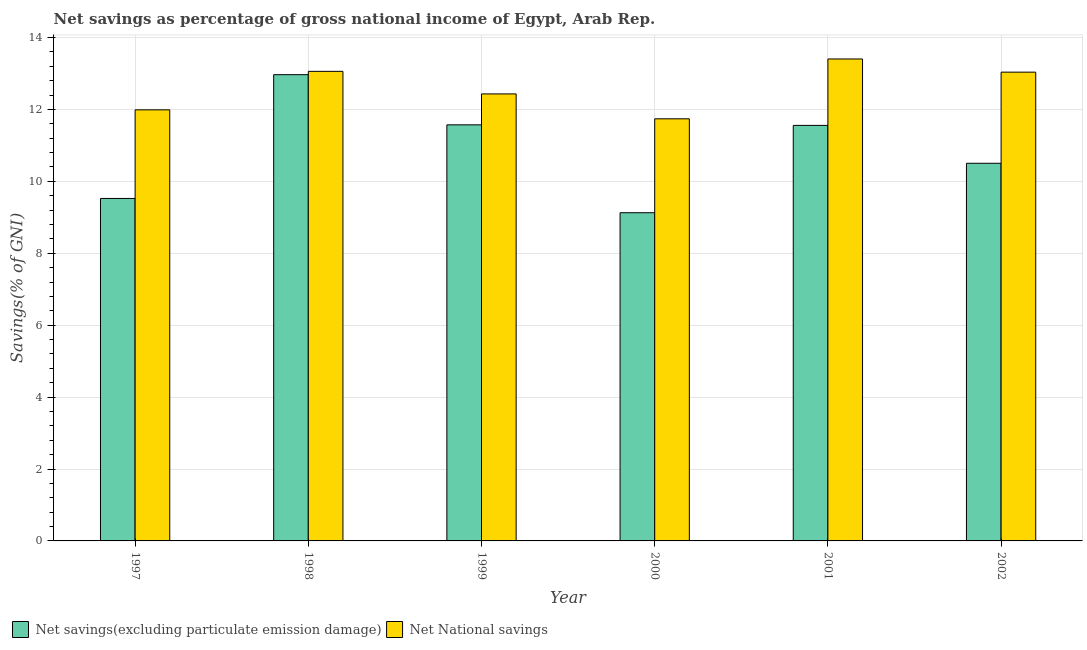Are the number of bars per tick equal to the number of legend labels?
Offer a very short reply. Yes. How many bars are there on the 2nd tick from the right?
Make the answer very short. 2. In how many cases, is the number of bars for a given year not equal to the number of legend labels?
Keep it short and to the point. 0. What is the net national savings in 1998?
Your response must be concise. 13.06. Across all years, what is the maximum net national savings?
Keep it short and to the point. 13.4. Across all years, what is the minimum net national savings?
Your answer should be very brief. 11.74. In which year was the net national savings maximum?
Your response must be concise. 2001. In which year was the net national savings minimum?
Your answer should be compact. 2000. What is the total net savings(excluding particulate emission damage) in the graph?
Ensure brevity in your answer.  65.25. What is the difference between the net savings(excluding particulate emission damage) in 1999 and that in 2000?
Offer a terse response. 2.44. What is the difference between the net national savings in 2001 and the net savings(excluding particulate emission damage) in 2002?
Give a very brief answer. 0.37. What is the average net savings(excluding particulate emission damage) per year?
Your answer should be compact. 10.87. In the year 2000, what is the difference between the net savings(excluding particulate emission damage) and net national savings?
Ensure brevity in your answer.  0. What is the ratio of the net national savings in 1998 to that in 1999?
Ensure brevity in your answer.  1.05. Is the net savings(excluding particulate emission damage) in 1999 less than that in 2002?
Your answer should be compact. No. What is the difference between the highest and the second highest net national savings?
Offer a terse response. 0.34. What is the difference between the highest and the lowest net national savings?
Offer a terse response. 1.66. What does the 1st bar from the left in 1997 represents?
Offer a terse response. Net savings(excluding particulate emission damage). What does the 2nd bar from the right in 1998 represents?
Offer a terse response. Net savings(excluding particulate emission damage). Does the graph contain grids?
Provide a succinct answer. Yes. Where does the legend appear in the graph?
Keep it short and to the point. Bottom left. How many legend labels are there?
Your answer should be very brief. 2. How are the legend labels stacked?
Keep it short and to the point. Horizontal. What is the title of the graph?
Your answer should be very brief. Net savings as percentage of gross national income of Egypt, Arab Rep. What is the label or title of the Y-axis?
Your response must be concise. Savings(% of GNI). What is the Savings(% of GNI) in Net savings(excluding particulate emission damage) in 1997?
Make the answer very short. 9.52. What is the Savings(% of GNI) of Net National savings in 1997?
Keep it short and to the point. 11.99. What is the Savings(% of GNI) in Net savings(excluding particulate emission damage) in 1998?
Keep it short and to the point. 12.97. What is the Savings(% of GNI) of Net National savings in 1998?
Provide a succinct answer. 13.06. What is the Savings(% of GNI) in Net savings(excluding particulate emission damage) in 1999?
Ensure brevity in your answer.  11.57. What is the Savings(% of GNI) of Net National savings in 1999?
Provide a succinct answer. 12.43. What is the Savings(% of GNI) in Net savings(excluding particulate emission damage) in 2000?
Offer a terse response. 9.13. What is the Savings(% of GNI) in Net National savings in 2000?
Your answer should be compact. 11.74. What is the Savings(% of GNI) of Net savings(excluding particulate emission damage) in 2001?
Keep it short and to the point. 11.56. What is the Savings(% of GNI) in Net National savings in 2001?
Make the answer very short. 13.4. What is the Savings(% of GNI) in Net savings(excluding particulate emission damage) in 2002?
Offer a terse response. 10.5. What is the Savings(% of GNI) of Net National savings in 2002?
Offer a very short reply. 13.04. Across all years, what is the maximum Savings(% of GNI) of Net savings(excluding particulate emission damage)?
Ensure brevity in your answer.  12.97. Across all years, what is the maximum Savings(% of GNI) in Net National savings?
Provide a succinct answer. 13.4. Across all years, what is the minimum Savings(% of GNI) in Net savings(excluding particulate emission damage)?
Ensure brevity in your answer.  9.13. Across all years, what is the minimum Savings(% of GNI) in Net National savings?
Make the answer very short. 11.74. What is the total Savings(% of GNI) in Net savings(excluding particulate emission damage) in the graph?
Provide a short and direct response. 65.25. What is the total Savings(% of GNI) of Net National savings in the graph?
Make the answer very short. 75.65. What is the difference between the Savings(% of GNI) of Net savings(excluding particulate emission damage) in 1997 and that in 1998?
Provide a succinct answer. -3.44. What is the difference between the Savings(% of GNI) of Net National savings in 1997 and that in 1998?
Your answer should be compact. -1.07. What is the difference between the Savings(% of GNI) in Net savings(excluding particulate emission damage) in 1997 and that in 1999?
Give a very brief answer. -2.05. What is the difference between the Savings(% of GNI) of Net National savings in 1997 and that in 1999?
Offer a very short reply. -0.44. What is the difference between the Savings(% of GNI) in Net savings(excluding particulate emission damage) in 1997 and that in 2000?
Offer a terse response. 0.4. What is the difference between the Savings(% of GNI) of Net National savings in 1997 and that in 2000?
Offer a terse response. 0.25. What is the difference between the Savings(% of GNI) of Net savings(excluding particulate emission damage) in 1997 and that in 2001?
Offer a very short reply. -2.03. What is the difference between the Savings(% of GNI) of Net National savings in 1997 and that in 2001?
Offer a terse response. -1.41. What is the difference between the Savings(% of GNI) in Net savings(excluding particulate emission damage) in 1997 and that in 2002?
Make the answer very short. -0.98. What is the difference between the Savings(% of GNI) in Net National savings in 1997 and that in 2002?
Offer a terse response. -1.05. What is the difference between the Savings(% of GNI) in Net savings(excluding particulate emission damage) in 1998 and that in 1999?
Provide a succinct answer. 1.39. What is the difference between the Savings(% of GNI) in Net National savings in 1998 and that in 1999?
Make the answer very short. 0.63. What is the difference between the Savings(% of GNI) of Net savings(excluding particulate emission damage) in 1998 and that in 2000?
Your response must be concise. 3.84. What is the difference between the Savings(% of GNI) in Net National savings in 1998 and that in 2000?
Offer a terse response. 1.32. What is the difference between the Savings(% of GNI) in Net savings(excluding particulate emission damage) in 1998 and that in 2001?
Your answer should be very brief. 1.41. What is the difference between the Savings(% of GNI) of Net National savings in 1998 and that in 2001?
Give a very brief answer. -0.34. What is the difference between the Savings(% of GNI) in Net savings(excluding particulate emission damage) in 1998 and that in 2002?
Your response must be concise. 2.46. What is the difference between the Savings(% of GNI) in Net National savings in 1998 and that in 2002?
Ensure brevity in your answer.  0.02. What is the difference between the Savings(% of GNI) in Net savings(excluding particulate emission damage) in 1999 and that in 2000?
Provide a succinct answer. 2.44. What is the difference between the Savings(% of GNI) in Net National savings in 1999 and that in 2000?
Make the answer very short. 0.69. What is the difference between the Savings(% of GNI) of Net savings(excluding particulate emission damage) in 1999 and that in 2001?
Provide a short and direct response. 0.02. What is the difference between the Savings(% of GNI) in Net National savings in 1999 and that in 2001?
Offer a terse response. -0.97. What is the difference between the Savings(% of GNI) of Net savings(excluding particulate emission damage) in 1999 and that in 2002?
Keep it short and to the point. 1.07. What is the difference between the Savings(% of GNI) in Net National savings in 1999 and that in 2002?
Your answer should be compact. -0.61. What is the difference between the Savings(% of GNI) of Net savings(excluding particulate emission damage) in 2000 and that in 2001?
Ensure brevity in your answer.  -2.43. What is the difference between the Savings(% of GNI) in Net National savings in 2000 and that in 2001?
Provide a succinct answer. -1.66. What is the difference between the Savings(% of GNI) in Net savings(excluding particulate emission damage) in 2000 and that in 2002?
Give a very brief answer. -1.38. What is the difference between the Savings(% of GNI) in Net National savings in 2000 and that in 2002?
Ensure brevity in your answer.  -1.3. What is the difference between the Savings(% of GNI) in Net savings(excluding particulate emission damage) in 2001 and that in 2002?
Provide a succinct answer. 1.05. What is the difference between the Savings(% of GNI) in Net National savings in 2001 and that in 2002?
Keep it short and to the point. 0.37. What is the difference between the Savings(% of GNI) in Net savings(excluding particulate emission damage) in 1997 and the Savings(% of GNI) in Net National savings in 1998?
Make the answer very short. -3.53. What is the difference between the Savings(% of GNI) of Net savings(excluding particulate emission damage) in 1997 and the Savings(% of GNI) of Net National savings in 1999?
Ensure brevity in your answer.  -2.91. What is the difference between the Savings(% of GNI) of Net savings(excluding particulate emission damage) in 1997 and the Savings(% of GNI) of Net National savings in 2000?
Your response must be concise. -2.21. What is the difference between the Savings(% of GNI) in Net savings(excluding particulate emission damage) in 1997 and the Savings(% of GNI) in Net National savings in 2001?
Give a very brief answer. -3.88. What is the difference between the Savings(% of GNI) in Net savings(excluding particulate emission damage) in 1997 and the Savings(% of GNI) in Net National savings in 2002?
Your response must be concise. -3.51. What is the difference between the Savings(% of GNI) of Net savings(excluding particulate emission damage) in 1998 and the Savings(% of GNI) of Net National savings in 1999?
Make the answer very short. 0.53. What is the difference between the Savings(% of GNI) in Net savings(excluding particulate emission damage) in 1998 and the Savings(% of GNI) in Net National savings in 2000?
Your answer should be compact. 1.23. What is the difference between the Savings(% of GNI) in Net savings(excluding particulate emission damage) in 1998 and the Savings(% of GNI) in Net National savings in 2001?
Offer a terse response. -0.44. What is the difference between the Savings(% of GNI) of Net savings(excluding particulate emission damage) in 1998 and the Savings(% of GNI) of Net National savings in 2002?
Your response must be concise. -0.07. What is the difference between the Savings(% of GNI) of Net savings(excluding particulate emission damage) in 1999 and the Savings(% of GNI) of Net National savings in 2000?
Make the answer very short. -0.17. What is the difference between the Savings(% of GNI) of Net savings(excluding particulate emission damage) in 1999 and the Savings(% of GNI) of Net National savings in 2001?
Provide a succinct answer. -1.83. What is the difference between the Savings(% of GNI) of Net savings(excluding particulate emission damage) in 1999 and the Savings(% of GNI) of Net National savings in 2002?
Offer a very short reply. -1.47. What is the difference between the Savings(% of GNI) in Net savings(excluding particulate emission damage) in 2000 and the Savings(% of GNI) in Net National savings in 2001?
Offer a very short reply. -4.28. What is the difference between the Savings(% of GNI) of Net savings(excluding particulate emission damage) in 2000 and the Savings(% of GNI) of Net National savings in 2002?
Give a very brief answer. -3.91. What is the difference between the Savings(% of GNI) of Net savings(excluding particulate emission damage) in 2001 and the Savings(% of GNI) of Net National savings in 2002?
Make the answer very short. -1.48. What is the average Savings(% of GNI) in Net savings(excluding particulate emission damage) per year?
Give a very brief answer. 10.87. What is the average Savings(% of GNI) in Net National savings per year?
Provide a succinct answer. 12.61. In the year 1997, what is the difference between the Savings(% of GNI) in Net savings(excluding particulate emission damage) and Savings(% of GNI) in Net National savings?
Your answer should be very brief. -2.46. In the year 1998, what is the difference between the Savings(% of GNI) in Net savings(excluding particulate emission damage) and Savings(% of GNI) in Net National savings?
Provide a succinct answer. -0.09. In the year 1999, what is the difference between the Savings(% of GNI) in Net savings(excluding particulate emission damage) and Savings(% of GNI) in Net National savings?
Your response must be concise. -0.86. In the year 2000, what is the difference between the Savings(% of GNI) in Net savings(excluding particulate emission damage) and Savings(% of GNI) in Net National savings?
Ensure brevity in your answer.  -2.61. In the year 2001, what is the difference between the Savings(% of GNI) in Net savings(excluding particulate emission damage) and Savings(% of GNI) in Net National savings?
Provide a succinct answer. -1.85. In the year 2002, what is the difference between the Savings(% of GNI) of Net savings(excluding particulate emission damage) and Savings(% of GNI) of Net National savings?
Your response must be concise. -2.53. What is the ratio of the Savings(% of GNI) of Net savings(excluding particulate emission damage) in 1997 to that in 1998?
Provide a succinct answer. 0.73. What is the ratio of the Savings(% of GNI) of Net National savings in 1997 to that in 1998?
Provide a short and direct response. 0.92. What is the ratio of the Savings(% of GNI) of Net savings(excluding particulate emission damage) in 1997 to that in 1999?
Your answer should be compact. 0.82. What is the ratio of the Savings(% of GNI) of Net National savings in 1997 to that in 1999?
Make the answer very short. 0.96. What is the ratio of the Savings(% of GNI) of Net savings(excluding particulate emission damage) in 1997 to that in 2000?
Provide a succinct answer. 1.04. What is the ratio of the Savings(% of GNI) of Net National savings in 1997 to that in 2000?
Provide a succinct answer. 1.02. What is the ratio of the Savings(% of GNI) in Net savings(excluding particulate emission damage) in 1997 to that in 2001?
Your answer should be compact. 0.82. What is the ratio of the Savings(% of GNI) in Net National savings in 1997 to that in 2001?
Your answer should be very brief. 0.89. What is the ratio of the Savings(% of GNI) in Net savings(excluding particulate emission damage) in 1997 to that in 2002?
Offer a terse response. 0.91. What is the ratio of the Savings(% of GNI) of Net National savings in 1997 to that in 2002?
Make the answer very short. 0.92. What is the ratio of the Savings(% of GNI) in Net savings(excluding particulate emission damage) in 1998 to that in 1999?
Offer a very short reply. 1.12. What is the ratio of the Savings(% of GNI) in Net National savings in 1998 to that in 1999?
Offer a terse response. 1.05. What is the ratio of the Savings(% of GNI) of Net savings(excluding particulate emission damage) in 1998 to that in 2000?
Offer a very short reply. 1.42. What is the ratio of the Savings(% of GNI) in Net National savings in 1998 to that in 2000?
Provide a short and direct response. 1.11. What is the ratio of the Savings(% of GNI) in Net savings(excluding particulate emission damage) in 1998 to that in 2001?
Your answer should be very brief. 1.12. What is the ratio of the Savings(% of GNI) of Net National savings in 1998 to that in 2001?
Your answer should be very brief. 0.97. What is the ratio of the Savings(% of GNI) of Net savings(excluding particulate emission damage) in 1998 to that in 2002?
Offer a terse response. 1.23. What is the ratio of the Savings(% of GNI) in Net savings(excluding particulate emission damage) in 1999 to that in 2000?
Offer a terse response. 1.27. What is the ratio of the Savings(% of GNI) in Net National savings in 1999 to that in 2000?
Keep it short and to the point. 1.06. What is the ratio of the Savings(% of GNI) in Net savings(excluding particulate emission damage) in 1999 to that in 2001?
Your answer should be very brief. 1. What is the ratio of the Savings(% of GNI) in Net National savings in 1999 to that in 2001?
Offer a terse response. 0.93. What is the ratio of the Savings(% of GNI) in Net savings(excluding particulate emission damage) in 1999 to that in 2002?
Your response must be concise. 1.1. What is the ratio of the Savings(% of GNI) of Net National savings in 1999 to that in 2002?
Keep it short and to the point. 0.95. What is the ratio of the Savings(% of GNI) of Net savings(excluding particulate emission damage) in 2000 to that in 2001?
Offer a terse response. 0.79. What is the ratio of the Savings(% of GNI) of Net National savings in 2000 to that in 2001?
Make the answer very short. 0.88. What is the ratio of the Savings(% of GNI) of Net savings(excluding particulate emission damage) in 2000 to that in 2002?
Give a very brief answer. 0.87. What is the ratio of the Savings(% of GNI) in Net National savings in 2000 to that in 2002?
Provide a succinct answer. 0.9. What is the ratio of the Savings(% of GNI) of Net savings(excluding particulate emission damage) in 2001 to that in 2002?
Ensure brevity in your answer.  1.1. What is the ratio of the Savings(% of GNI) in Net National savings in 2001 to that in 2002?
Offer a terse response. 1.03. What is the difference between the highest and the second highest Savings(% of GNI) of Net savings(excluding particulate emission damage)?
Your answer should be compact. 1.39. What is the difference between the highest and the second highest Savings(% of GNI) of Net National savings?
Provide a succinct answer. 0.34. What is the difference between the highest and the lowest Savings(% of GNI) of Net savings(excluding particulate emission damage)?
Make the answer very short. 3.84. What is the difference between the highest and the lowest Savings(% of GNI) of Net National savings?
Your answer should be compact. 1.66. 